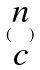Convert formula to latex. <formula><loc_0><loc_0><loc_500><loc_500>( \begin{matrix} n \\ c \end{matrix} )</formula> 